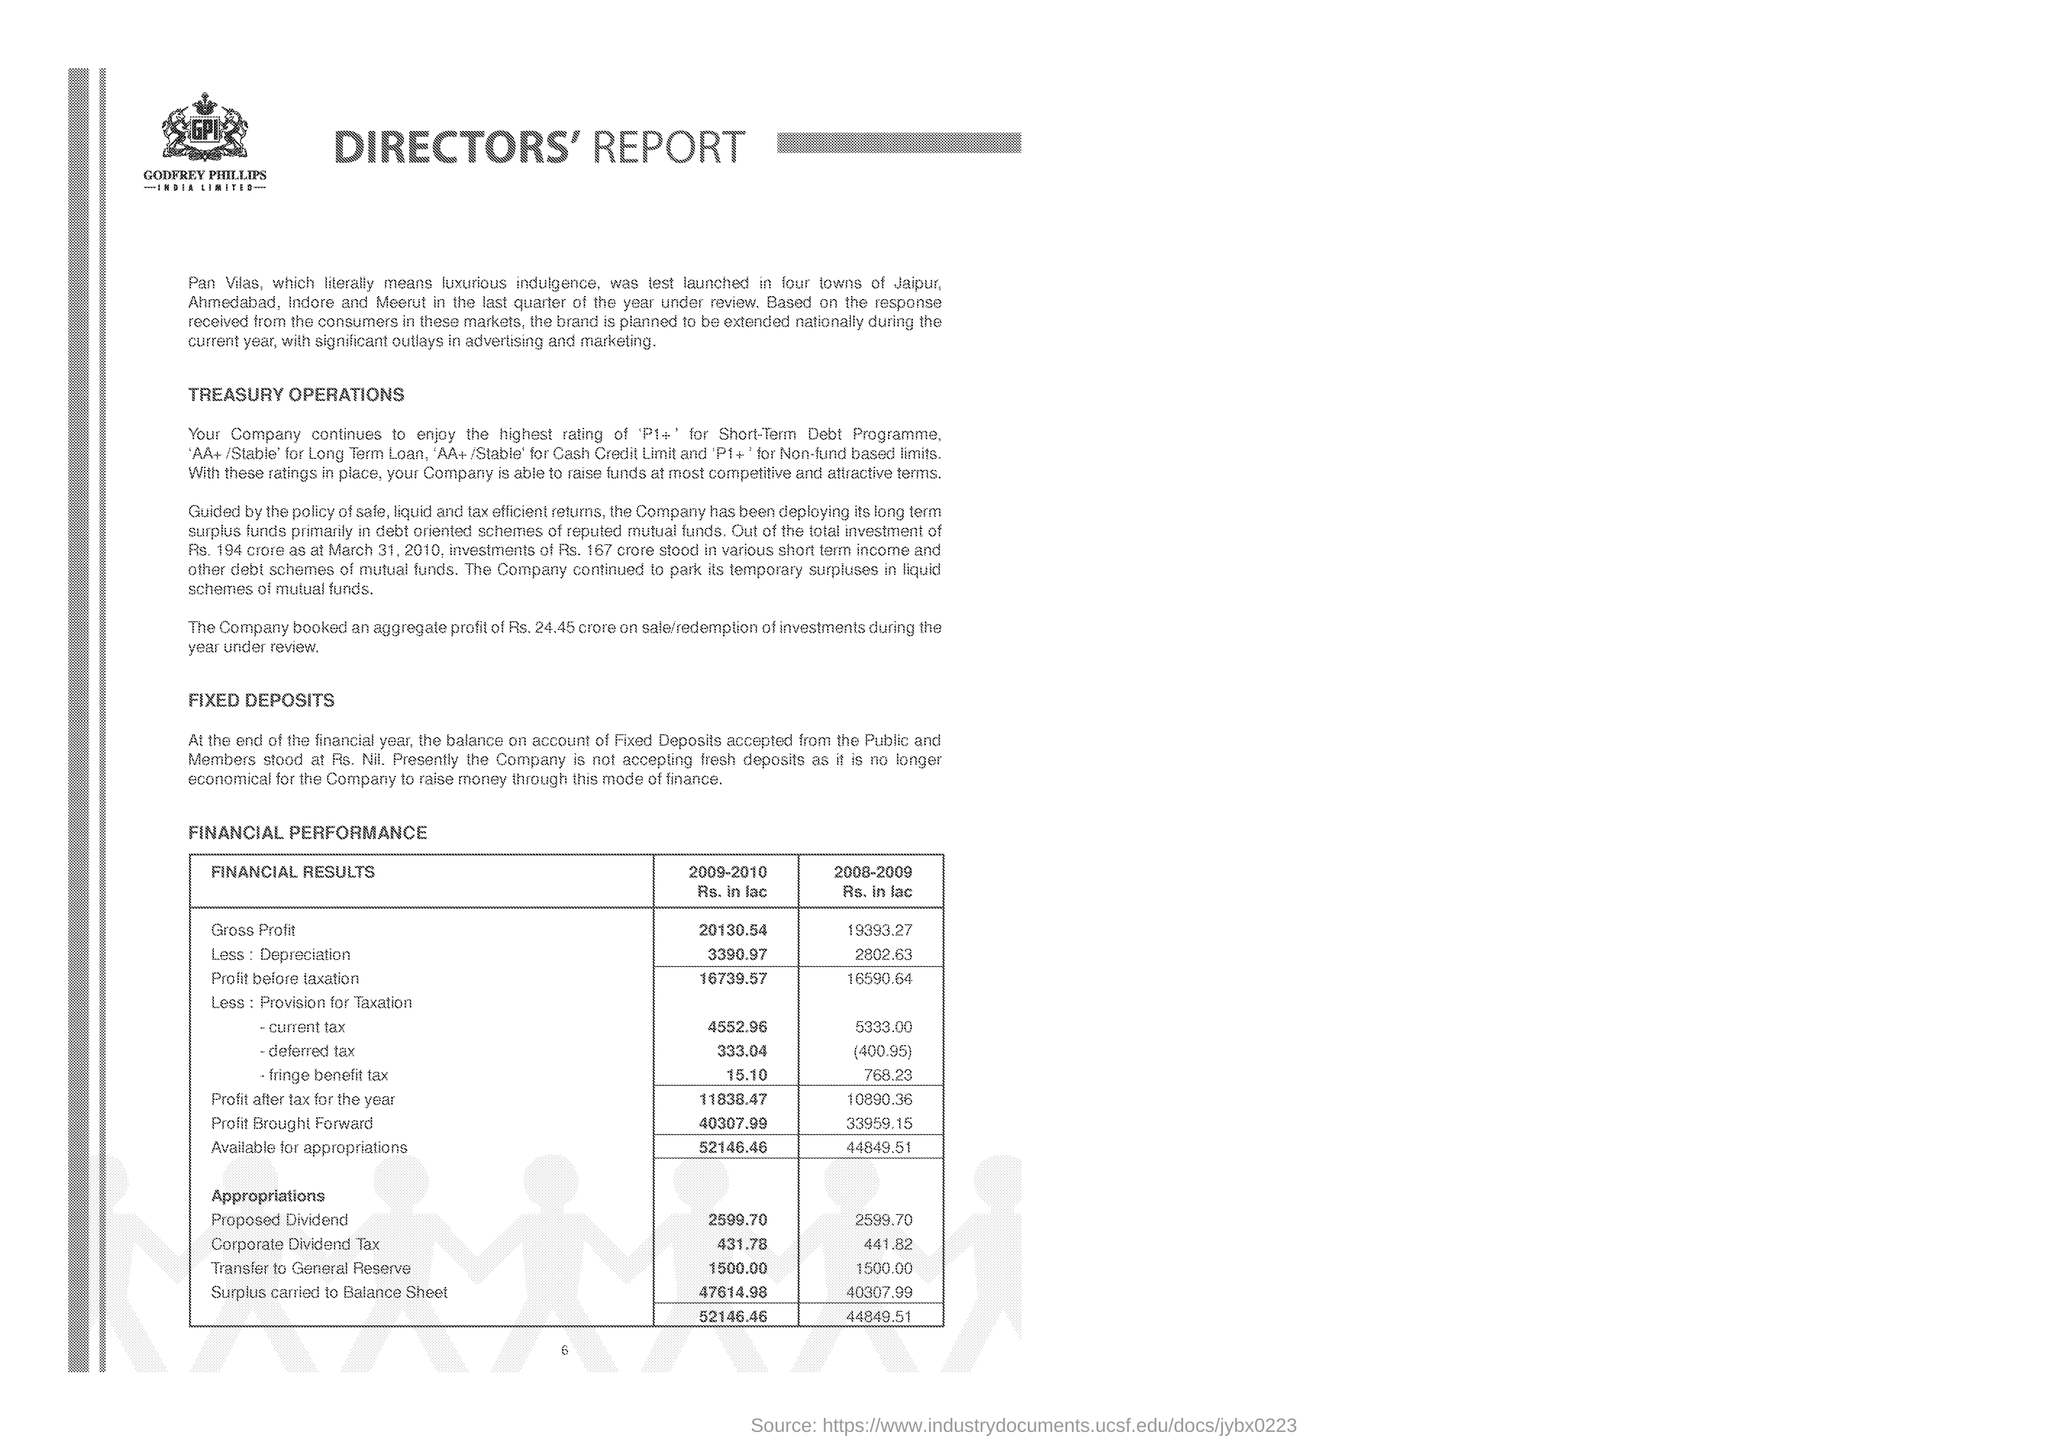Identify some key points in this picture. The gross profit in the year 2009-2010 was Rs. 30.54 crores. The surplus as of the year 2009-2010 was 47,614.98 lac. The gross profit in the year 2008-2009 was Rs. 19,393.27 lakhs. In the year 2009-2010, the corporate dividend tax was 431.78. 